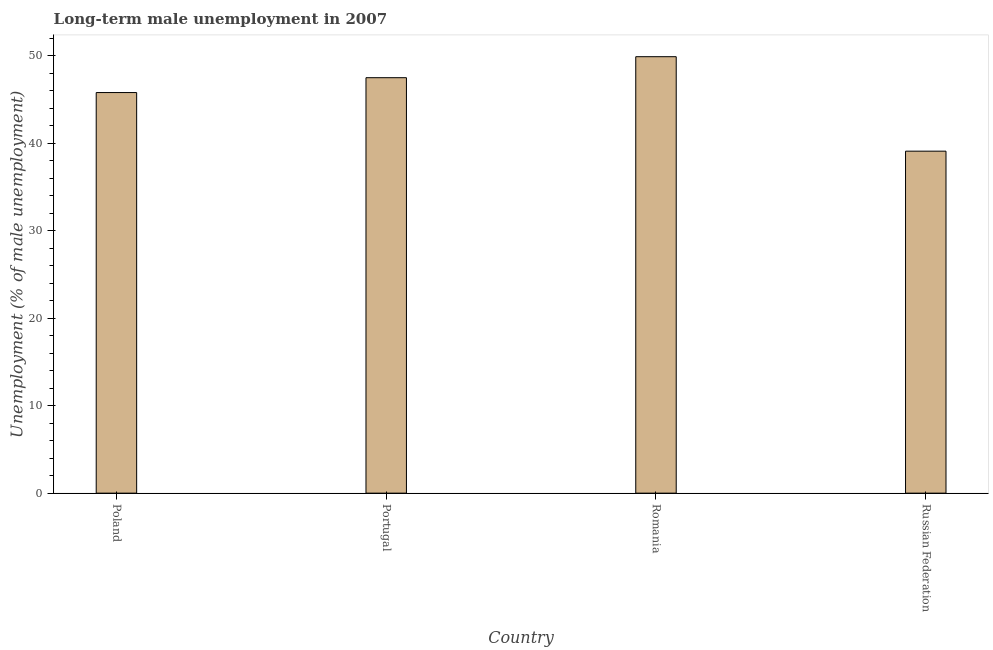Does the graph contain grids?
Your response must be concise. No. What is the title of the graph?
Your response must be concise. Long-term male unemployment in 2007. What is the label or title of the X-axis?
Your response must be concise. Country. What is the label or title of the Y-axis?
Your response must be concise. Unemployment (% of male unemployment). What is the long-term male unemployment in Poland?
Your answer should be very brief. 45.8. Across all countries, what is the maximum long-term male unemployment?
Give a very brief answer. 49.9. Across all countries, what is the minimum long-term male unemployment?
Offer a terse response. 39.1. In which country was the long-term male unemployment maximum?
Your response must be concise. Romania. In which country was the long-term male unemployment minimum?
Offer a very short reply. Russian Federation. What is the sum of the long-term male unemployment?
Provide a short and direct response. 182.3. What is the difference between the long-term male unemployment in Portugal and Russian Federation?
Keep it short and to the point. 8.4. What is the average long-term male unemployment per country?
Keep it short and to the point. 45.58. What is the median long-term male unemployment?
Your answer should be compact. 46.65. Is the long-term male unemployment in Portugal less than that in Russian Federation?
Offer a very short reply. No. Is the difference between the long-term male unemployment in Romania and Russian Federation greater than the difference between any two countries?
Offer a terse response. Yes. What is the difference between the highest and the lowest long-term male unemployment?
Provide a short and direct response. 10.8. How many bars are there?
Provide a short and direct response. 4. Are all the bars in the graph horizontal?
Provide a succinct answer. No. How many countries are there in the graph?
Ensure brevity in your answer.  4. Are the values on the major ticks of Y-axis written in scientific E-notation?
Offer a very short reply. No. What is the Unemployment (% of male unemployment) of Poland?
Provide a succinct answer. 45.8. What is the Unemployment (% of male unemployment) of Portugal?
Ensure brevity in your answer.  47.5. What is the Unemployment (% of male unemployment) of Romania?
Give a very brief answer. 49.9. What is the Unemployment (% of male unemployment) of Russian Federation?
Make the answer very short. 39.1. What is the difference between the Unemployment (% of male unemployment) in Poland and Romania?
Keep it short and to the point. -4.1. What is the difference between the Unemployment (% of male unemployment) in Portugal and Romania?
Ensure brevity in your answer.  -2.4. What is the difference between the Unemployment (% of male unemployment) in Portugal and Russian Federation?
Provide a succinct answer. 8.4. What is the difference between the Unemployment (% of male unemployment) in Romania and Russian Federation?
Your response must be concise. 10.8. What is the ratio of the Unemployment (% of male unemployment) in Poland to that in Romania?
Provide a short and direct response. 0.92. What is the ratio of the Unemployment (% of male unemployment) in Poland to that in Russian Federation?
Provide a short and direct response. 1.17. What is the ratio of the Unemployment (% of male unemployment) in Portugal to that in Russian Federation?
Your response must be concise. 1.22. What is the ratio of the Unemployment (% of male unemployment) in Romania to that in Russian Federation?
Provide a short and direct response. 1.28. 